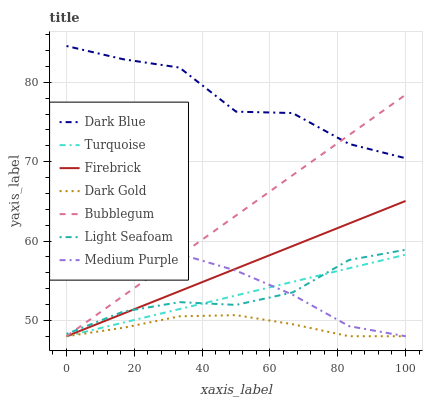Does Firebrick have the minimum area under the curve?
Answer yes or no. No. Does Firebrick have the maximum area under the curve?
Answer yes or no. No. Is Dark Gold the smoothest?
Answer yes or no. No. Is Dark Gold the roughest?
Answer yes or no. No. Does Dark Blue have the lowest value?
Answer yes or no. No. Does Firebrick have the highest value?
Answer yes or no. No. Is Dark Gold less than Dark Blue?
Answer yes or no. Yes. Is Light Seafoam greater than Dark Gold?
Answer yes or no. Yes. Does Dark Gold intersect Dark Blue?
Answer yes or no. No. 